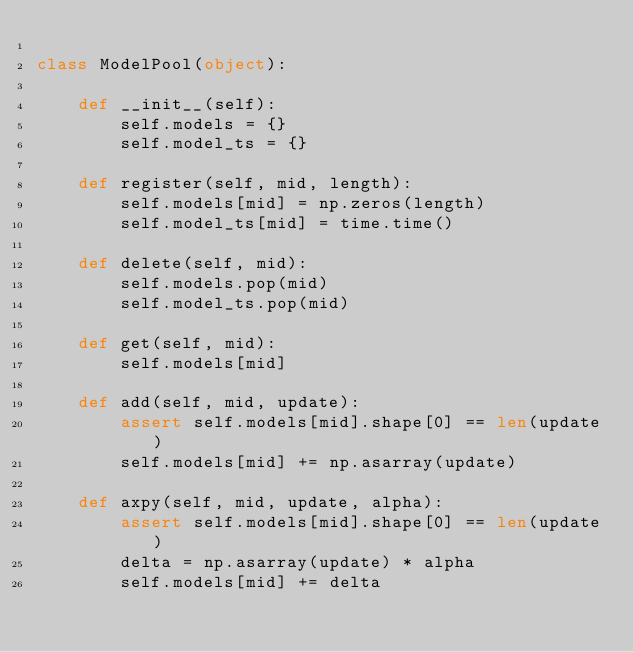Convert code to text. <code><loc_0><loc_0><loc_500><loc_500><_Python_>
class ModelPool(object):

    def __init__(self):
        self.models = {}
        self.model_ts = {}

    def register(self, mid, length):
        self.models[mid] = np.zeros(length)
        self.model_ts[mid] = time.time()

    def delete(self, mid):
        self.models.pop(mid)
        self.model_ts.pop(mid)

    def get(self, mid):
        self.models[mid]

    def add(self, mid, update):
        assert self.models[mid].shape[0] == len(update)
        self.models[mid] += np.asarray(update)

    def axpy(self, mid, update, alpha):
        assert self.models[mid].shape[0] == len(update)
        delta = np.asarray(update) * alpha
        self.models[mid] += delta
</code> 